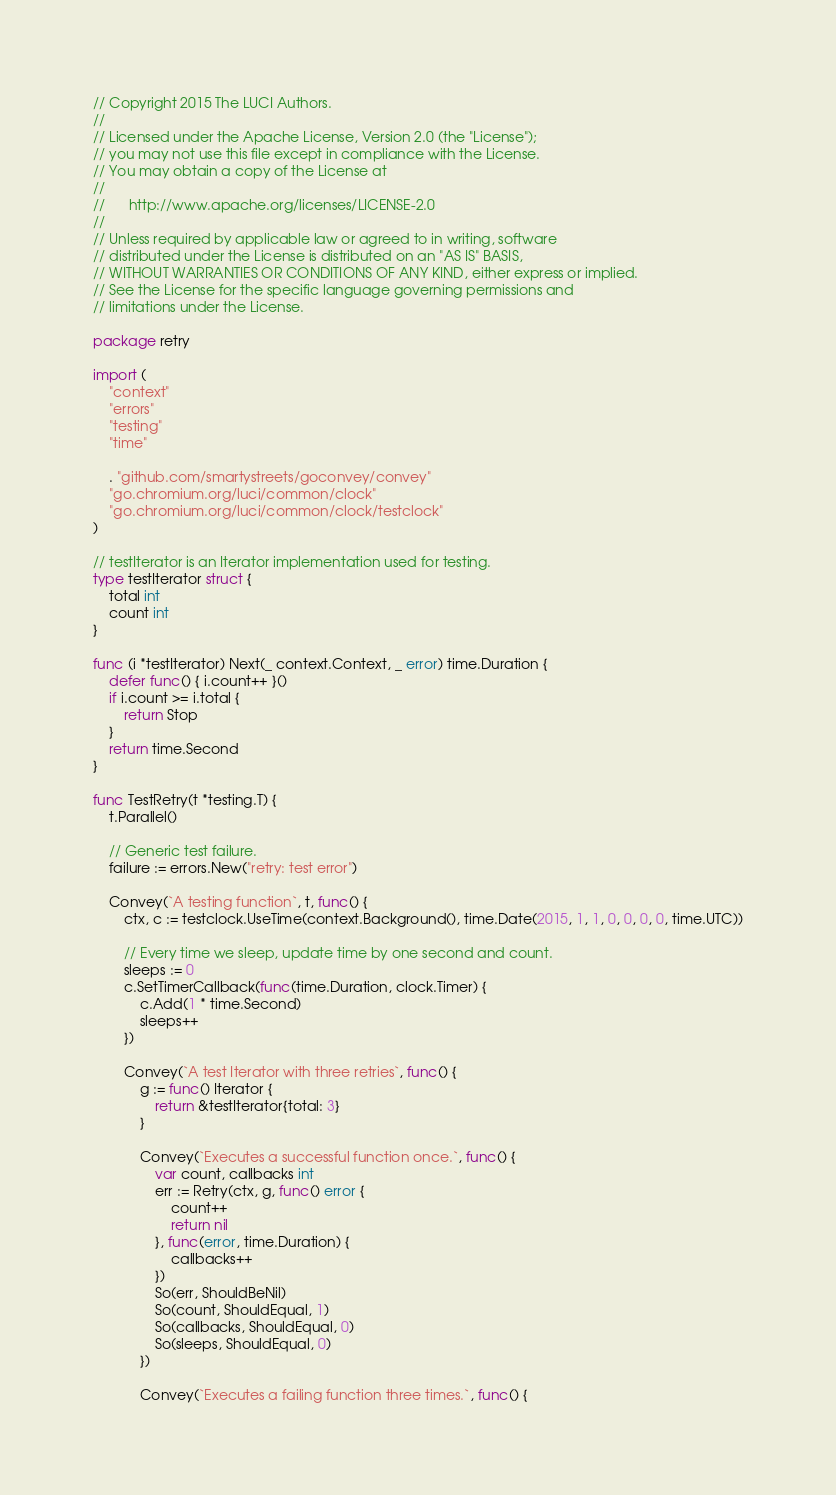Convert code to text. <code><loc_0><loc_0><loc_500><loc_500><_Go_>// Copyright 2015 The LUCI Authors.
//
// Licensed under the Apache License, Version 2.0 (the "License");
// you may not use this file except in compliance with the License.
// You may obtain a copy of the License at
//
//      http://www.apache.org/licenses/LICENSE-2.0
//
// Unless required by applicable law or agreed to in writing, software
// distributed under the License is distributed on an "AS IS" BASIS,
// WITHOUT WARRANTIES OR CONDITIONS OF ANY KIND, either express or implied.
// See the License for the specific language governing permissions and
// limitations under the License.

package retry

import (
	"context"
	"errors"
	"testing"
	"time"

	. "github.com/smartystreets/goconvey/convey"
	"go.chromium.org/luci/common/clock"
	"go.chromium.org/luci/common/clock/testclock"
)

// testIterator is an Iterator implementation used for testing.
type testIterator struct {
	total int
	count int
}

func (i *testIterator) Next(_ context.Context, _ error) time.Duration {
	defer func() { i.count++ }()
	if i.count >= i.total {
		return Stop
	}
	return time.Second
}

func TestRetry(t *testing.T) {
	t.Parallel()

	// Generic test failure.
	failure := errors.New("retry: test error")

	Convey(`A testing function`, t, func() {
		ctx, c := testclock.UseTime(context.Background(), time.Date(2015, 1, 1, 0, 0, 0, 0, time.UTC))

		// Every time we sleep, update time by one second and count.
		sleeps := 0
		c.SetTimerCallback(func(time.Duration, clock.Timer) {
			c.Add(1 * time.Second)
			sleeps++
		})

		Convey(`A test Iterator with three retries`, func() {
			g := func() Iterator {
				return &testIterator{total: 3}
			}

			Convey(`Executes a successful function once.`, func() {
				var count, callbacks int
				err := Retry(ctx, g, func() error {
					count++
					return nil
				}, func(error, time.Duration) {
					callbacks++
				})
				So(err, ShouldBeNil)
				So(count, ShouldEqual, 1)
				So(callbacks, ShouldEqual, 0)
				So(sleeps, ShouldEqual, 0)
			})

			Convey(`Executes a failing function three times.`, func() {</code> 